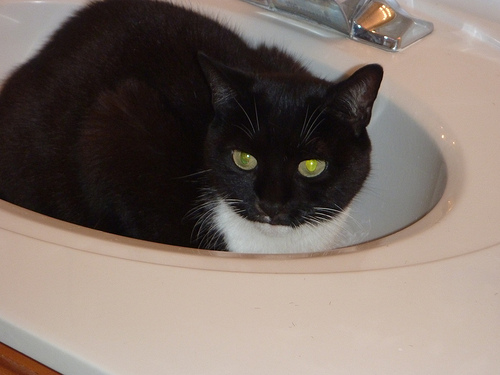Can you describe the environment in which the cat is located? The cat is in a domestic bathroom setting, likely a part of a home. It's resting in a white sink that you typically find in such a room, and there's a visible faucet indicating it's a functional area used by the household. Is there anything unusual about the cat's location? While it's not uncommon for cats to seek out unique resting spots, a sink is not a typical resting place for most pets. It may suggest that the cat enjoys the coolness of the porcelain, or it might simply be a personal quirky preference. 